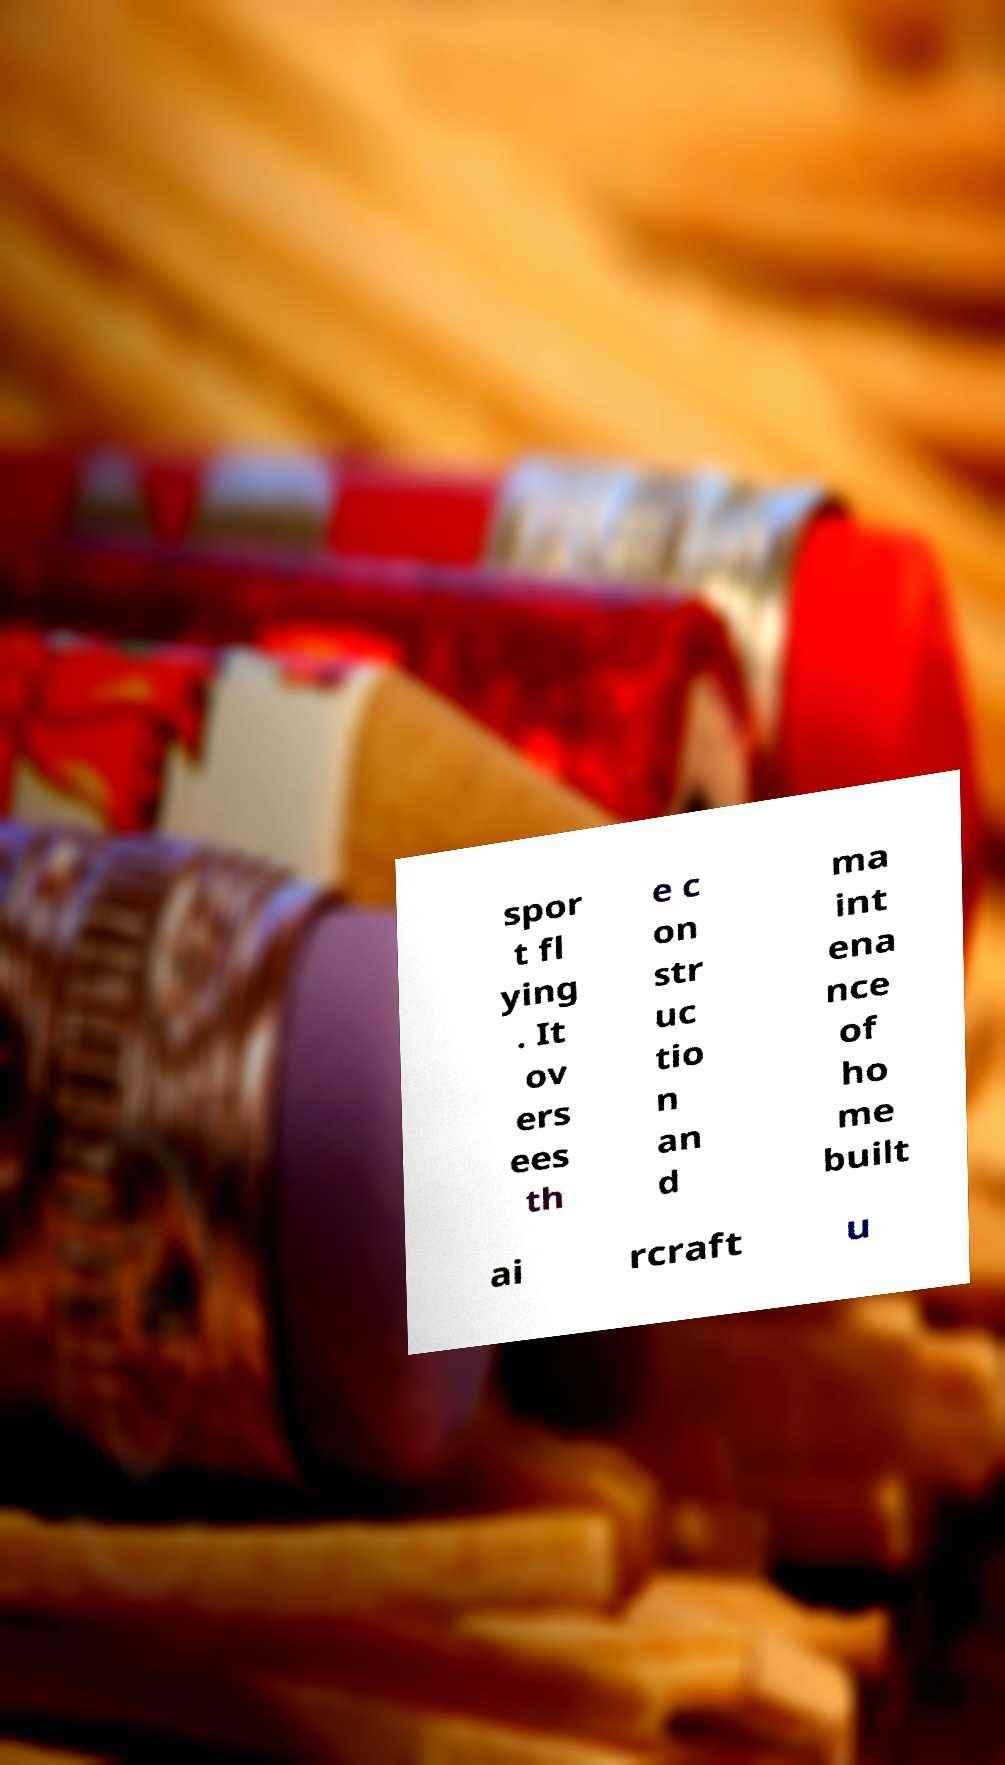Please identify and transcribe the text found in this image. spor t fl ying . It ov ers ees th e c on str uc tio n an d ma int ena nce of ho me built ai rcraft u 